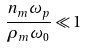Convert formula to latex. <formula><loc_0><loc_0><loc_500><loc_500>\frac { n _ { m } \omega _ { p } } { \rho _ { m } \omega _ { 0 } } \ll 1</formula> 